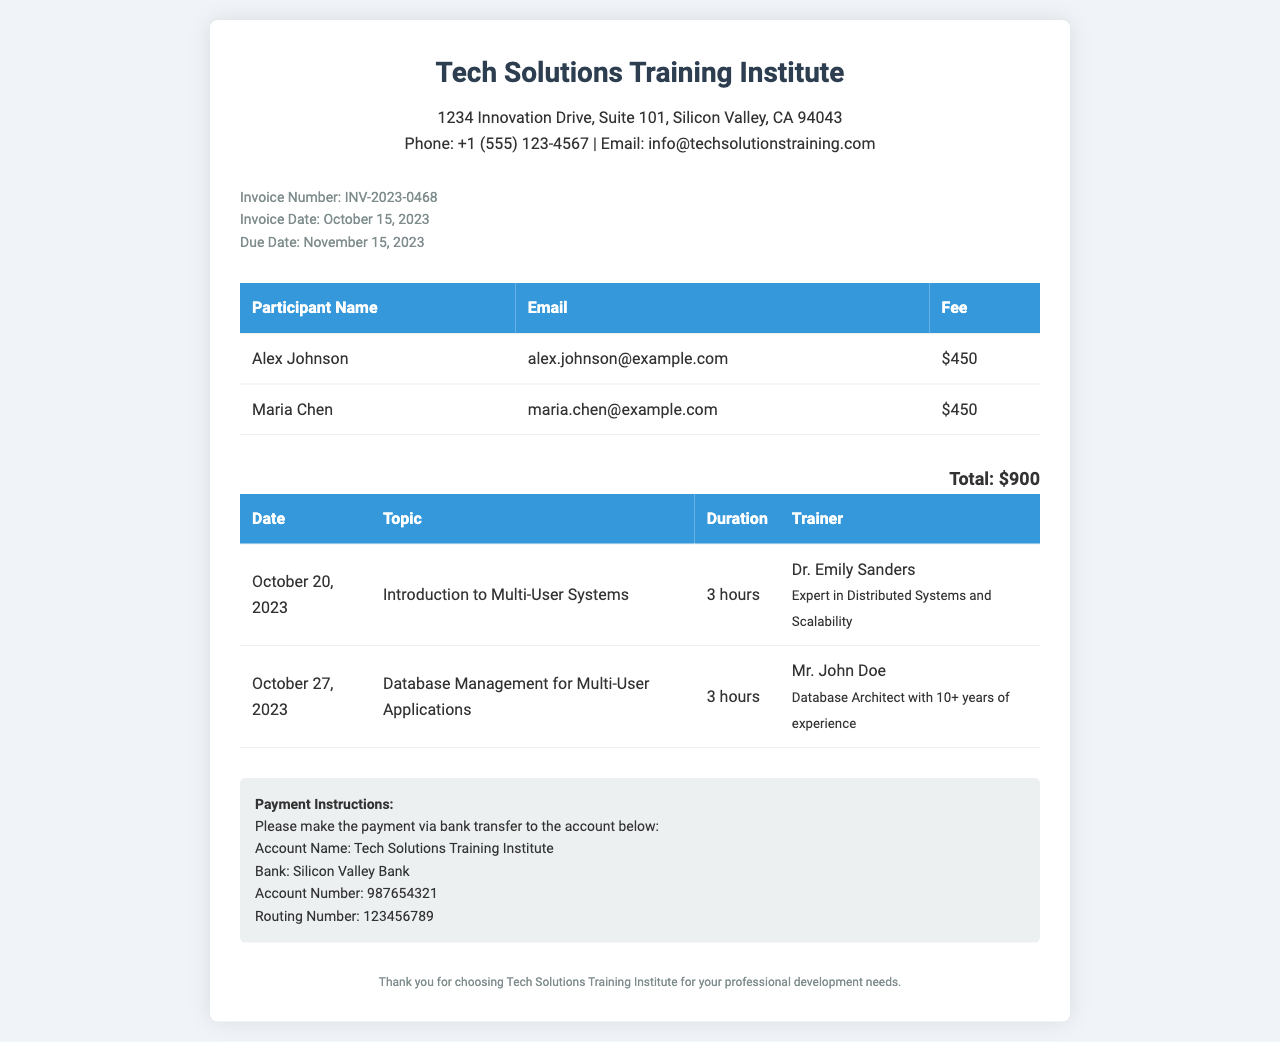What is the invoice number? The invoice number is specifically stated in the document as INV-2023-0468.
Answer: INV-2023-0468 What is the due date for the invoice? The due date is mentioned in the document, which is November 15, 2023.
Answer: November 15, 2023 Who is the trainer for the first session? The document lists Dr. Emily Sanders as the trainer for the first session on October 20, 2023.
Answer: Dr. Emily Sanders How much is the fee per participant? Each participant's fee is specified in the table as $450.
Answer: $450 What is the total fee for all participants? The total fee is calculated as $450 for each of the two participants, resulting in $900 total.
Answer: $900 Which topic is covered in the second training session? The document outlines "Database Management for Multi-User Applications" as the topic for the second session on October 27, 2023.
Answer: Database Management for Multi-User Applications How long is each training session? Each training session is stated to last for 3 hours.
Answer: 3 hours What bank should payments be made to? The document specifies that payments should be made to Silicon Valley Bank.
Answer: Silicon Valley Bank Who is the participant with the email "maria.chen@example.com"? The document lists Maria Chen as the participant associated with that email address.
Answer: Maria Chen 